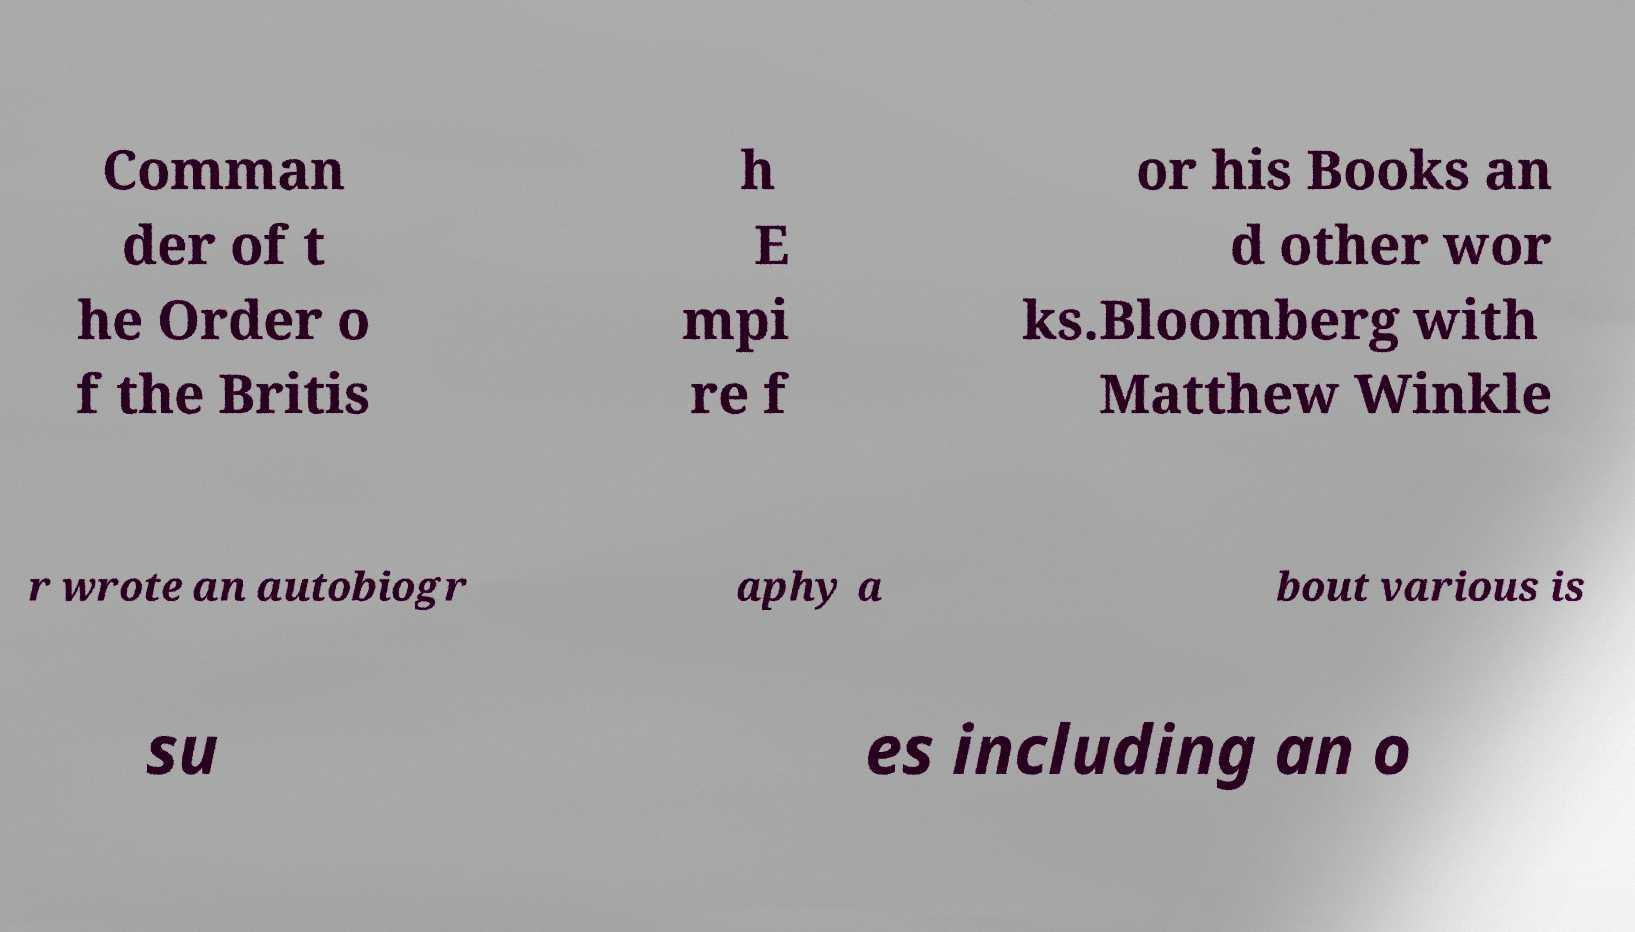Can you read and provide the text displayed in the image?This photo seems to have some interesting text. Can you extract and type it out for me? Comman der of t he Order o f the Britis h E mpi re f or his Books an d other wor ks.Bloomberg with Matthew Winkle r wrote an autobiogr aphy a bout various is su es including an o 